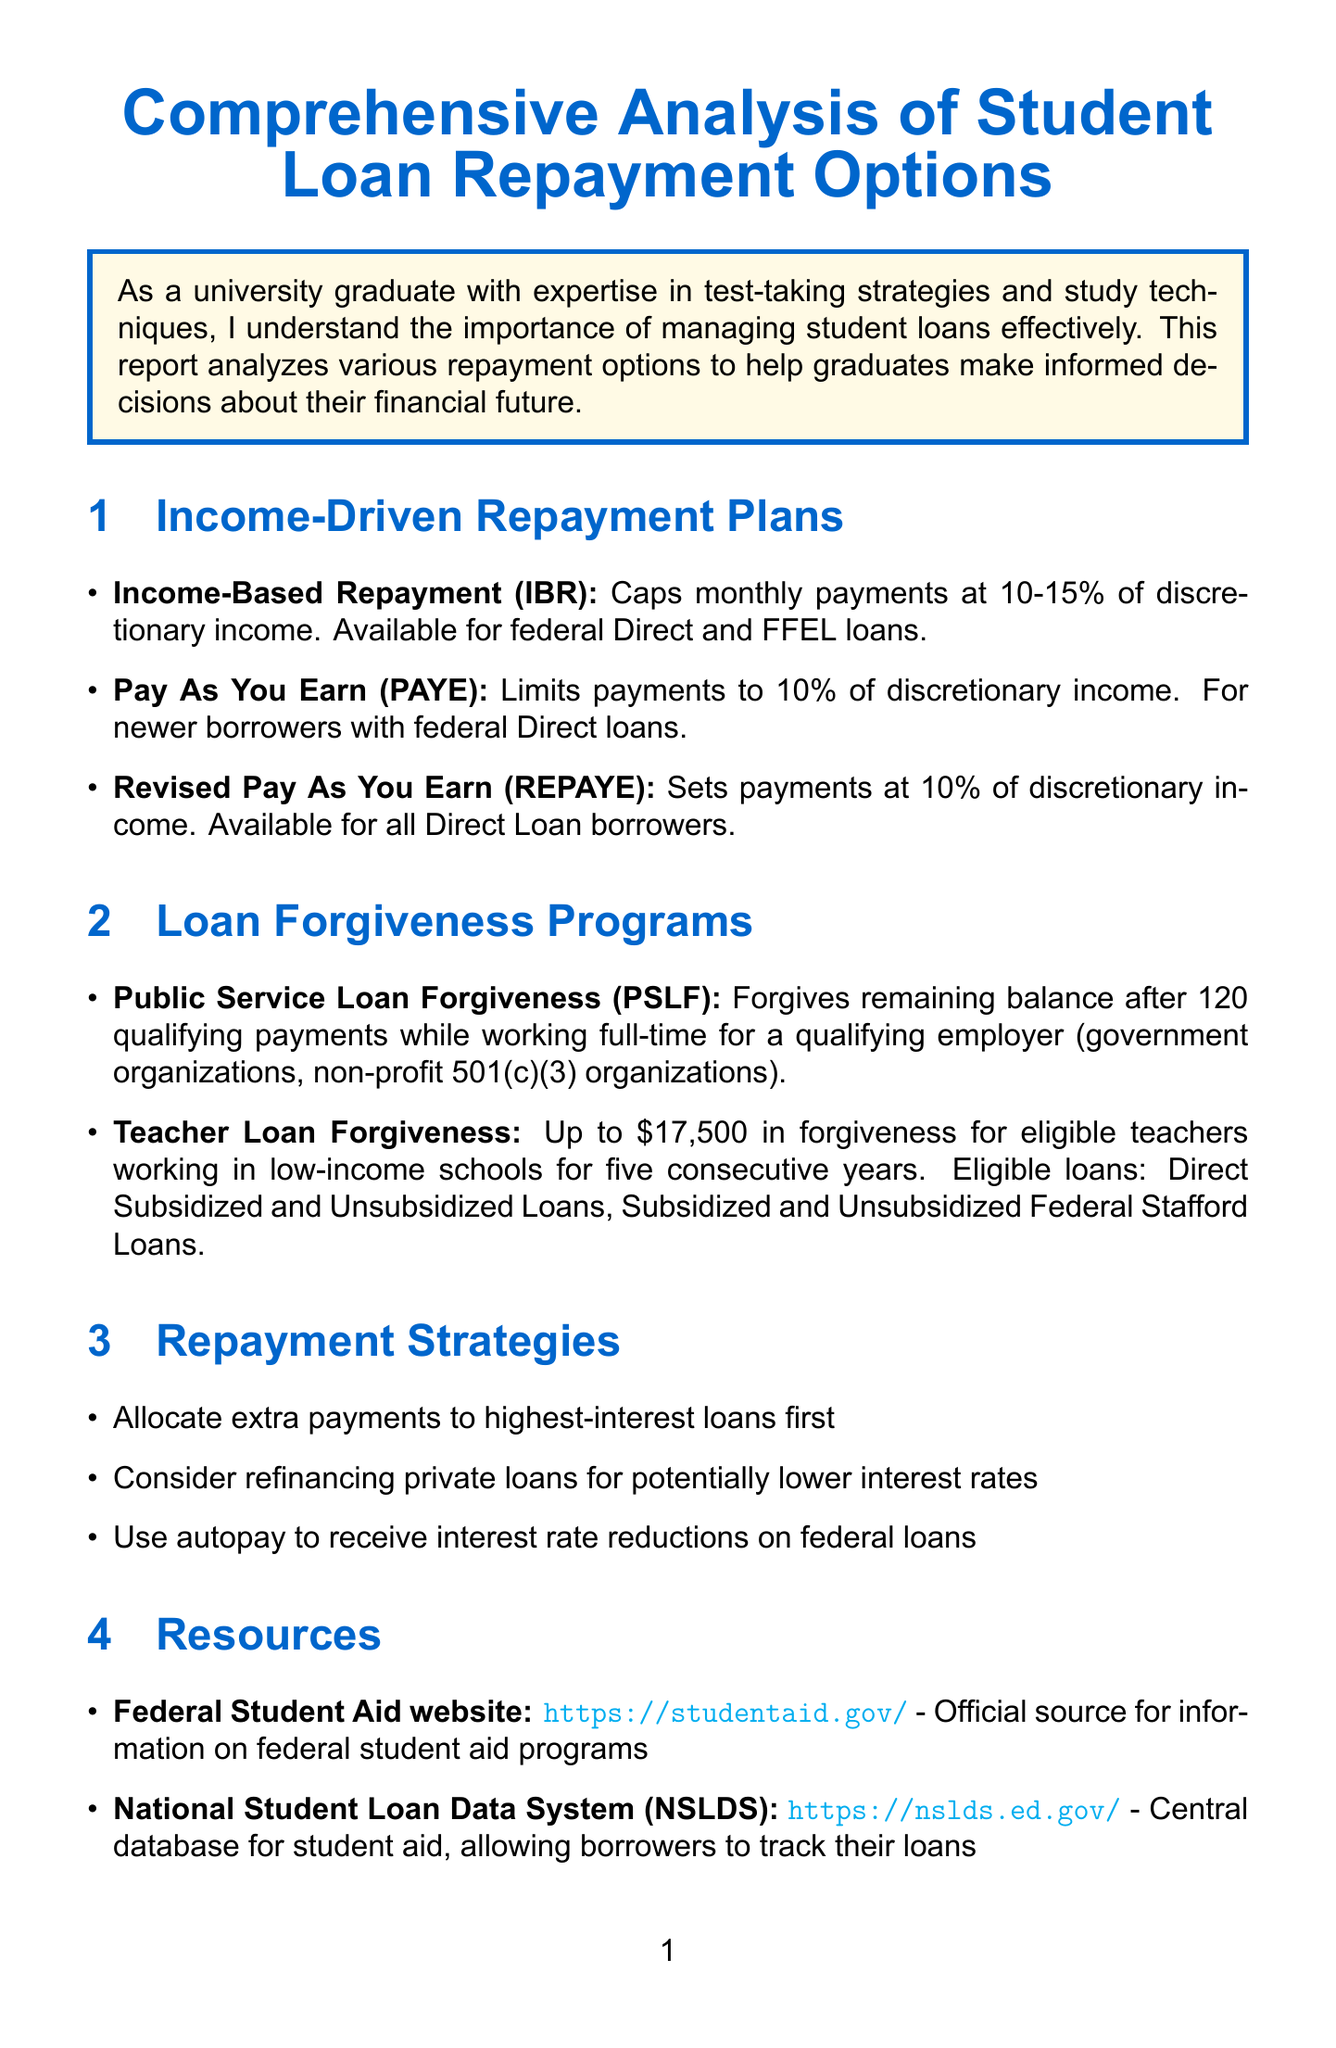What does IBR stand for? IBR stands for Income-Based Repayment, which is one of the income-driven repayment plans mentioned in the document.
Answer: Income-Based Repayment What percentage of discretionary income does PAYE limit payments to? The document states that PAYE limits payments to 10% of discretionary income.
Answer: 10% How many qualifying payments are required for Public Service Loan Forgiveness? The document specifies that 120 qualifying payments are required for Public Service Loan Forgiveness.
Answer: 120 What is one recommended repayment strategy? The document lists various repayment strategies, one of which is to allocate extra payments to highest-interest loans first.
Answer: Allocate extra payments to highest-interest loans first Which organization types qualify for Public Service Loan Forgiveness? The document lists government organizations and non-profit 501(c)(3) organizations as qualifying employers for Public Service Loan Forgiveness.
Answer: Government organizations, Non-profit 501(c)(3) organizations What is the maximum amount forgiven under Teacher Loan Forgiveness? The document indicates that up to $17,500 can be forgiven under Teacher Loan Forgiveness for eligible teachers.
Answer: $17,500 Where can one find information on federal student aid programs? The document refers to the Federal Student Aid website as the official source for this information.
Answer: Federal Student Aid website What is the conclusion about managing student debt? The conclusion emphasizes that understanding and choosing the right repayment option is crucial for managing student debt effectively.
Answer: Choosing the right repayment option is crucial 